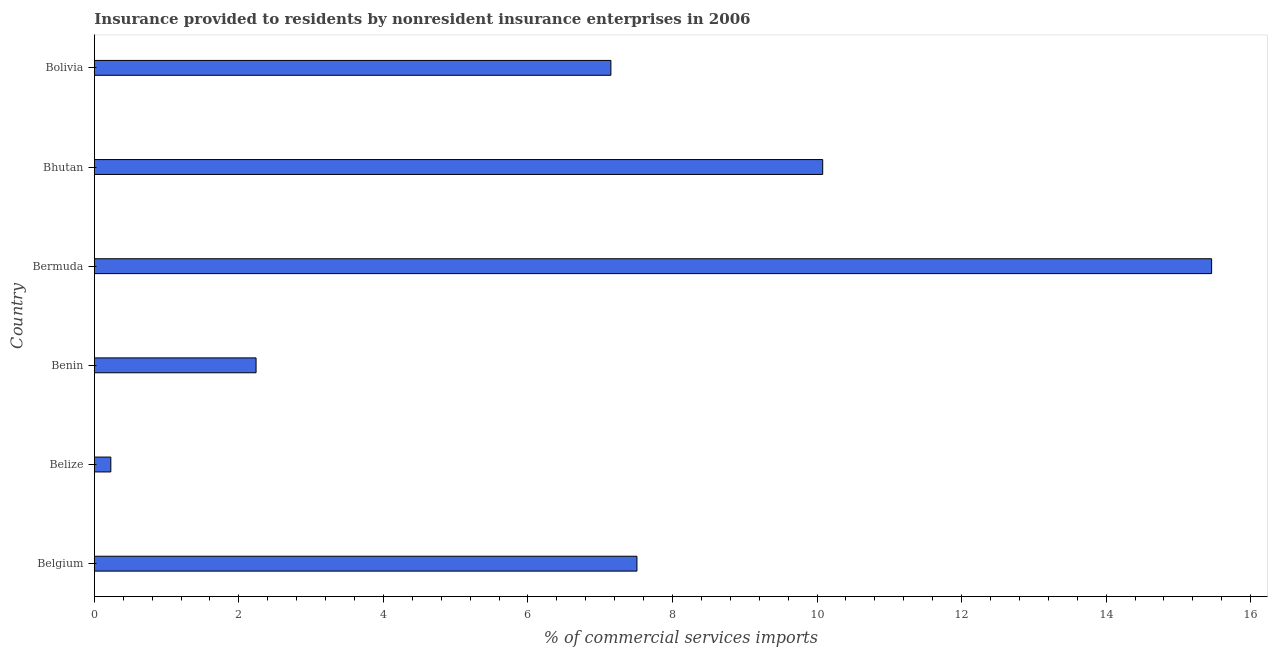Does the graph contain grids?
Keep it short and to the point. No. What is the title of the graph?
Provide a short and direct response. Insurance provided to residents by nonresident insurance enterprises in 2006. What is the label or title of the X-axis?
Offer a terse response. % of commercial services imports. What is the insurance provided by non-residents in Belize?
Keep it short and to the point. 0.23. Across all countries, what is the maximum insurance provided by non-residents?
Your answer should be very brief. 15.46. Across all countries, what is the minimum insurance provided by non-residents?
Offer a very short reply. 0.23. In which country was the insurance provided by non-residents maximum?
Offer a terse response. Bermuda. In which country was the insurance provided by non-residents minimum?
Offer a very short reply. Belize. What is the sum of the insurance provided by non-residents?
Provide a succinct answer. 42.66. What is the difference between the insurance provided by non-residents in Belize and Bhutan?
Your answer should be very brief. -9.85. What is the average insurance provided by non-residents per country?
Your response must be concise. 7.11. What is the median insurance provided by non-residents?
Offer a very short reply. 7.33. What is the ratio of the insurance provided by non-residents in Belgium to that in Bhutan?
Give a very brief answer. 0.74. Is the difference between the insurance provided by non-residents in Bhutan and Bolivia greater than the difference between any two countries?
Give a very brief answer. No. What is the difference between the highest and the second highest insurance provided by non-residents?
Your response must be concise. 5.38. What is the difference between the highest and the lowest insurance provided by non-residents?
Your answer should be compact. 15.23. In how many countries, is the insurance provided by non-residents greater than the average insurance provided by non-residents taken over all countries?
Provide a short and direct response. 4. Are the values on the major ticks of X-axis written in scientific E-notation?
Make the answer very short. No. What is the % of commercial services imports of Belgium?
Give a very brief answer. 7.51. What is the % of commercial services imports of Belize?
Offer a terse response. 0.23. What is the % of commercial services imports of Benin?
Give a very brief answer. 2.24. What is the % of commercial services imports of Bermuda?
Give a very brief answer. 15.46. What is the % of commercial services imports in Bhutan?
Ensure brevity in your answer.  10.08. What is the % of commercial services imports of Bolivia?
Your answer should be compact. 7.15. What is the difference between the % of commercial services imports in Belgium and Belize?
Provide a short and direct response. 7.28. What is the difference between the % of commercial services imports in Belgium and Benin?
Your answer should be very brief. 5.27. What is the difference between the % of commercial services imports in Belgium and Bermuda?
Keep it short and to the point. -7.95. What is the difference between the % of commercial services imports in Belgium and Bhutan?
Provide a succinct answer. -2.57. What is the difference between the % of commercial services imports in Belgium and Bolivia?
Your response must be concise. 0.36. What is the difference between the % of commercial services imports in Belize and Benin?
Make the answer very short. -2.01. What is the difference between the % of commercial services imports in Belize and Bermuda?
Provide a short and direct response. -15.23. What is the difference between the % of commercial services imports in Belize and Bhutan?
Provide a short and direct response. -9.85. What is the difference between the % of commercial services imports in Belize and Bolivia?
Provide a succinct answer. -6.92. What is the difference between the % of commercial services imports in Benin and Bermuda?
Make the answer very short. -13.22. What is the difference between the % of commercial services imports in Benin and Bhutan?
Offer a terse response. -7.84. What is the difference between the % of commercial services imports in Benin and Bolivia?
Provide a short and direct response. -4.91. What is the difference between the % of commercial services imports in Bermuda and Bhutan?
Your answer should be very brief. 5.38. What is the difference between the % of commercial services imports in Bermuda and Bolivia?
Your response must be concise. 8.31. What is the difference between the % of commercial services imports in Bhutan and Bolivia?
Make the answer very short. 2.93. What is the ratio of the % of commercial services imports in Belgium to that in Belize?
Provide a short and direct response. 32.89. What is the ratio of the % of commercial services imports in Belgium to that in Benin?
Ensure brevity in your answer.  3.35. What is the ratio of the % of commercial services imports in Belgium to that in Bermuda?
Your response must be concise. 0.49. What is the ratio of the % of commercial services imports in Belgium to that in Bhutan?
Your answer should be very brief. 0.74. What is the ratio of the % of commercial services imports in Belize to that in Benin?
Your answer should be very brief. 0.1. What is the ratio of the % of commercial services imports in Belize to that in Bermuda?
Ensure brevity in your answer.  0.01. What is the ratio of the % of commercial services imports in Belize to that in Bhutan?
Provide a short and direct response. 0.02. What is the ratio of the % of commercial services imports in Belize to that in Bolivia?
Offer a very short reply. 0.03. What is the ratio of the % of commercial services imports in Benin to that in Bermuda?
Your answer should be very brief. 0.14. What is the ratio of the % of commercial services imports in Benin to that in Bhutan?
Provide a short and direct response. 0.22. What is the ratio of the % of commercial services imports in Benin to that in Bolivia?
Your response must be concise. 0.31. What is the ratio of the % of commercial services imports in Bermuda to that in Bhutan?
Your answer should be compact. 1.53. What is the ratio of the % of commercial services imports in Bermuda to that in Bolivia?
Offer a terse response. 2.16. What is the ratio of the % of commercial services imports in Bhutan to that in Bolivia?
Ensure brevity in your answer.  1.41. 